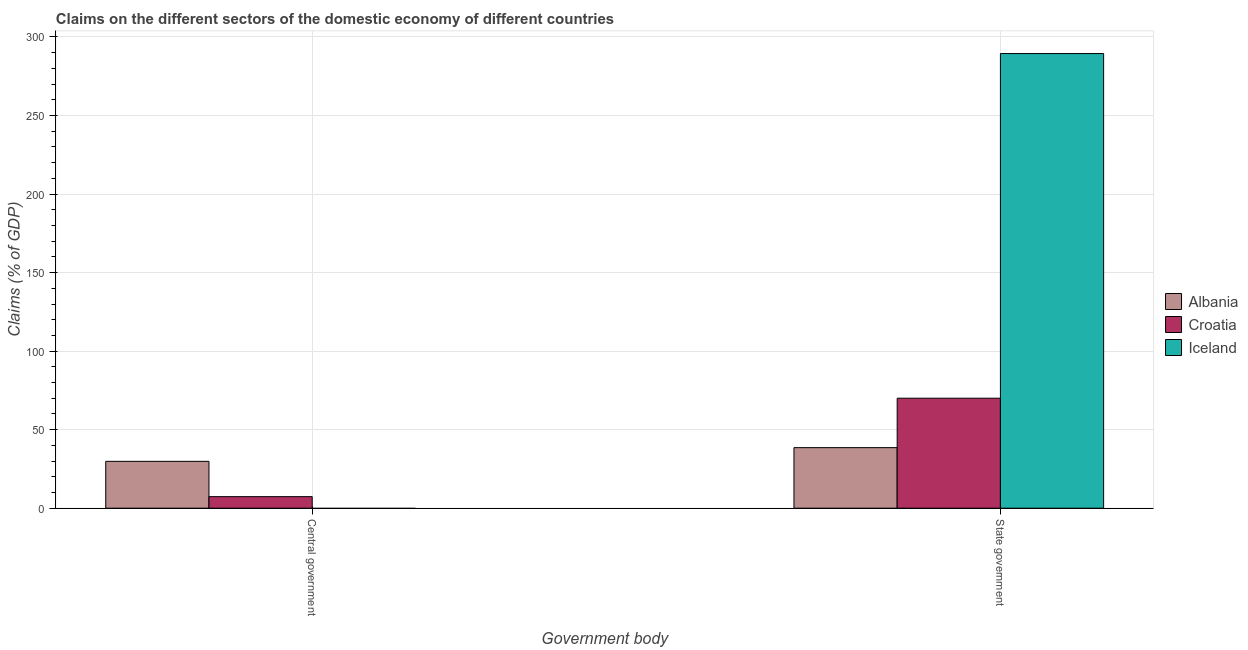How many groups of bars are there?
Offer a terse response. 2. How many bars are there on the 2nd tick from the left?
Ensure brevity in your answer.  3. How many bars are there on the 2nd tick from the right?
Provide a short and direct response. 2. What is the label of the 2nd group of bars from the left?
Provide a succinct answer. State government. What is the claims on central government in Iceland?
Offer a very short reply. 0. Across all countries, what is the maximum claims on state government?
Keep it short and to the point. 289.45. Across all countries, what is the minimum claims on central government?
Ensure brevity in your answer.  0. In which country was the claims on central government maximum?
Your response must be concise. Albania. What is the total claims on state government in the graph?
Your response must be concise. 398.03. What is the difference between the claims on state government in Iceland and that in Albania?
Ensure brevity in your answer.  250.91. What is the difference between the claims on state government in Albania and the claims on central government in Iceland?
Your answer should be very brief. 38.55. What is the average claims on central government per country?
Give a very brief answer. 12.4. What is the difference between the claims on central government and claims on state government in Croatia?
Offer a very short reply. -62.67. In how many countries, is the claims on central government greater than 230 %?
Offer a terse response. 0. What is the ratio of the claims on central government in Albania to that in Croatia?
Your answer should be compact. 4.06. How many bars are there?
Make the answer very short. 5. How many countries are there in the graph?
Your response must be concise. 3. What is the difference between two consecutive major ticks on the Y-axis?
Your answer should be very brief. 50. What is the title of the graph?
Offer a terse response. Claims on the different sectors of the domestic economy of different countries. Does "European Union" appear as one of the legend labels in the graph?
Give a very brief answer. No. What is the label or title of the X-axis?
Your answer should be compact. Government body. What is the label or title of the Y-axis?
Provide a succinct answer. Claims (% of GDP). What is the Claims (% of GDP) of Albania in Central government?
Your answer should be very brief. 29.83. What is the Claims (% of GDP) of Croatia in Central government?
Your answer should be compact. 7.35. What is the Claims (% of GDP) in Albania in State government?
Provide a short and direct response. 38.55. What is the Claims (% of GDP) of Croatia in State government?
Ensure brevity in your answer.  70.03. What is the Claims (% of GDP) in Iceland in State government?
Give a very brief answer. 289.45. Across all Government body, what is the maximum Claims (% of GDP) of Albania?
Make the answer very short. 38.55. Across all Government body, what is the maximum Claims (% of GDP) in Croatia?
Provide a succinct answer. 70.03. Across all Government body, what is the maximum Claims (% of GDP) of Iceland?
Provide a short and direct response. 289.45. Across all Government body, what is the minimum Claims (% of GDP) in Albania?
Your response must be concise. 29.83. Across all Government body, what is the minimum Claims (% of GDP) of Croatia?
Keep it short and to the point. 7.35. Across all Government body, what is the minimum Claims (% of GDP) of Iceland?
Offer a very short reply. 0. What is the total Claims (% of GDP) in Albania in the graph?
Make the answer very short. 68.38. What is the total Claims (% of GDP) of Croatia in the graph?
Give a very brief answer. 77.38. What is the total Claims (% of GDP) in Iceland in the graph?
Ensure brevity in your answer.  289.45. What is the difference between the Claims (% of GDP) in Albania in Central government and that in State government?
Make the answer very short. -8.71. What is the difference between the Claims (% of GDP) in Croatia in Central government and that in State government?
Offer a terse response. -62.67. What is the difference between the Claims (% of GDP) in Albania in Central government and the Claims (% of GDP) in Croatia in State government?
Offer a very short reply. -40.19. What is the difference between the Claims (% of GDP) in Albania in Central government and the Claims (% of GDP) in Iceland in State government?
Make the answer very short. -259.62. What is the difference between the Claims (% of GDP) of Croatia in Central government and the Claims (% of GDP) of Iceland in State government?
Your answer should be compact. -282.1. What is the average Claims (% of GDP) in Albania per Government body?
Your response must be concise. 34.19. What is the average Claims (% of GDP) of Croatia per Government body?
Offer a terse response. 38.69. What is the average Claims (% of GDP) in Iceland per Government body?
Give a very brief answer. 144.73. What is the difference between the Claims (% of GDP) of Albania and Claims (% of GDP) of Croatia in Central government?
Your answer should be very brief. 22.48. What is the difference between the Claims (% of GDP) in Albania and Claims (% of GDP) in Croatia in State government?
Your response must be concise. -31.48. What is the difference between the Claims (% of GDP) of Albania and Claims (% of GDP) of Iceland in State government?
Your answer should be compact. -250.91. What is the difference between the Claims (% of GDP) in Croatia and Claims (% of GDP) in Iceland in State government?
Your answer should be compact. -219.43. What is the ratio of the Claims (% of GDP) in Albania in Central government to that in State government?
Provide a succinct answer. 0.77. What is the ratio of the Claims (% of GDP) of Croatia in Central government to that in State government?
Make the answer very short. 0.1. What is the difference between the highest and the second highest Claims (% of GDP) in Albania?
Your answer should be very brief. 8.71. What is the difference between the highest and the second highest Claims (% of GDP) of Croatia?
Your response must be concise. 62.67. What is the difference between the highest and the lowest Claims (% of GDP) of Albania?
Ensure brevity in your answer.  8.71. What is the difference between the highest and the lowest Claims (% of GDP) of Croatia?
Your answer should be very brief. 62.67. What is the difference between the highest and the lowest Claims (% of GDP) in Iceland?
Keep it short and to the point. 289.45. 